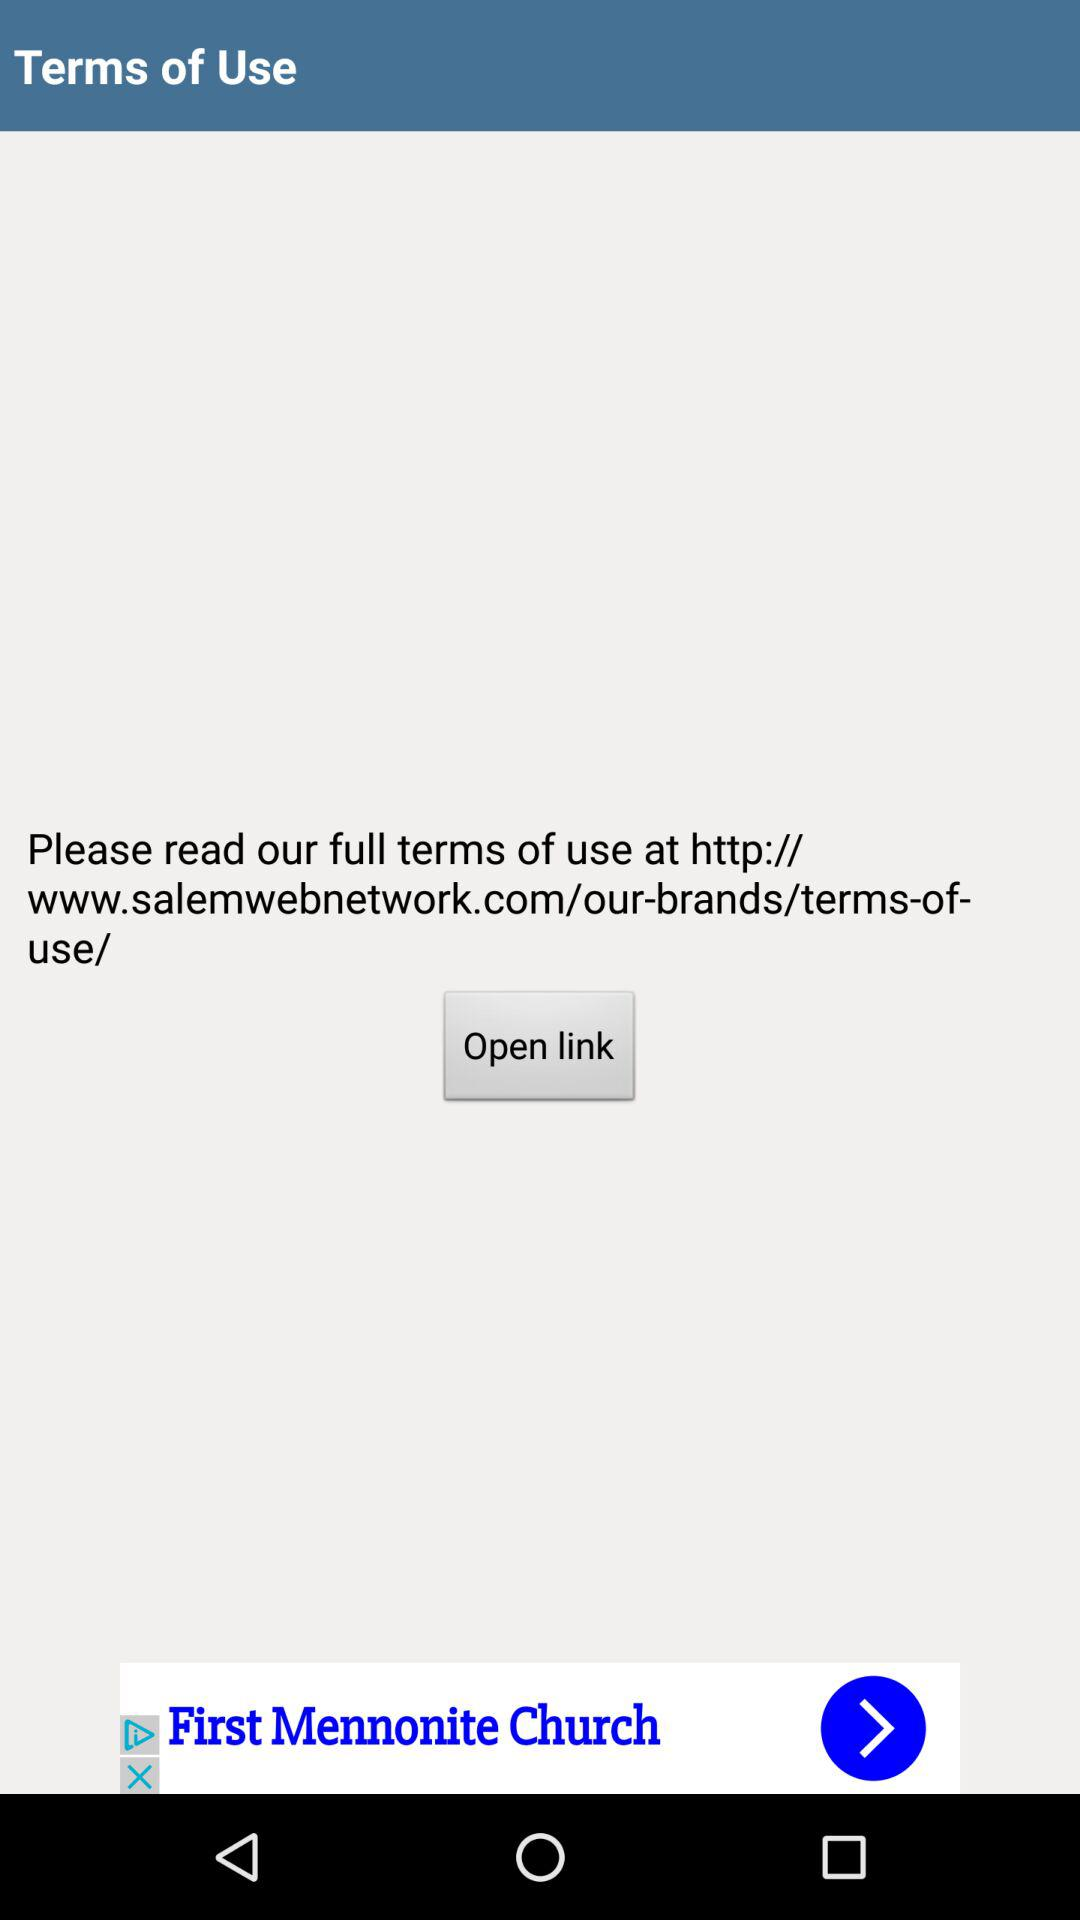What is the link to read the full terms of use? The link is http://www.salemwebnetwork.com/our-brands/terms-of-use/. 